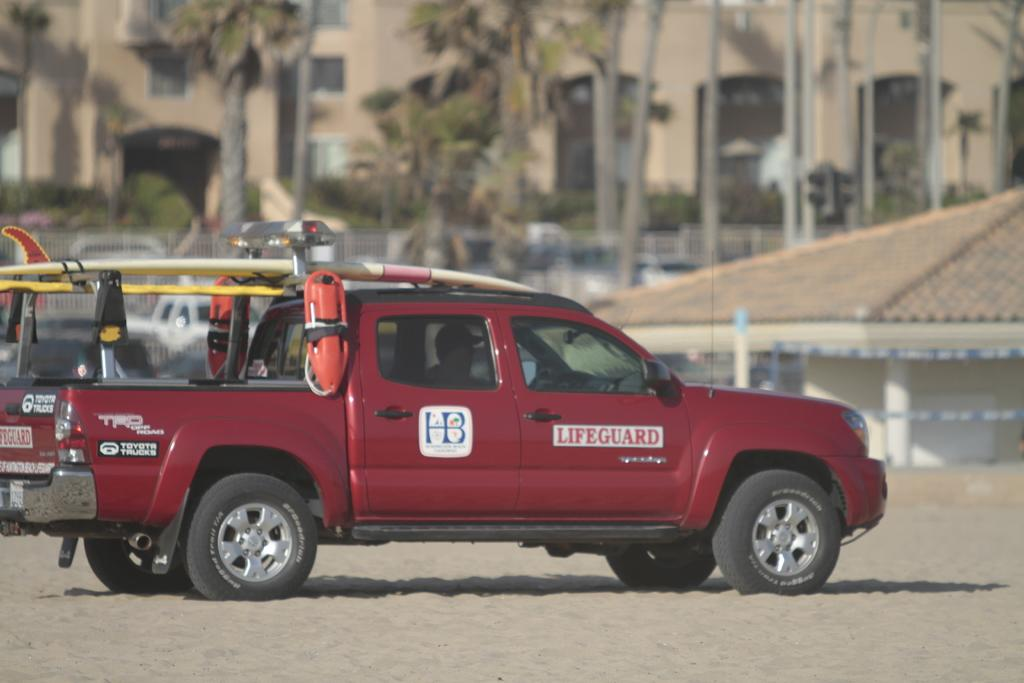What is the main subject of the image? There is a car in the image. Can you describe the person inside the car? There is a person inside the car. What type of terrain is visible in the image? The ground appears to be sand. What can be seen in the background of the image? There are trees and buildings in the background of the image. What type of education is being offered at the camp in the image? There is no camp present in the image, so it is not possible to determine what type of education might be offered. How does the car burn fuel in the image? The image does not show the car burning fuel, so it is not possible to determine how it operates in that regard. 